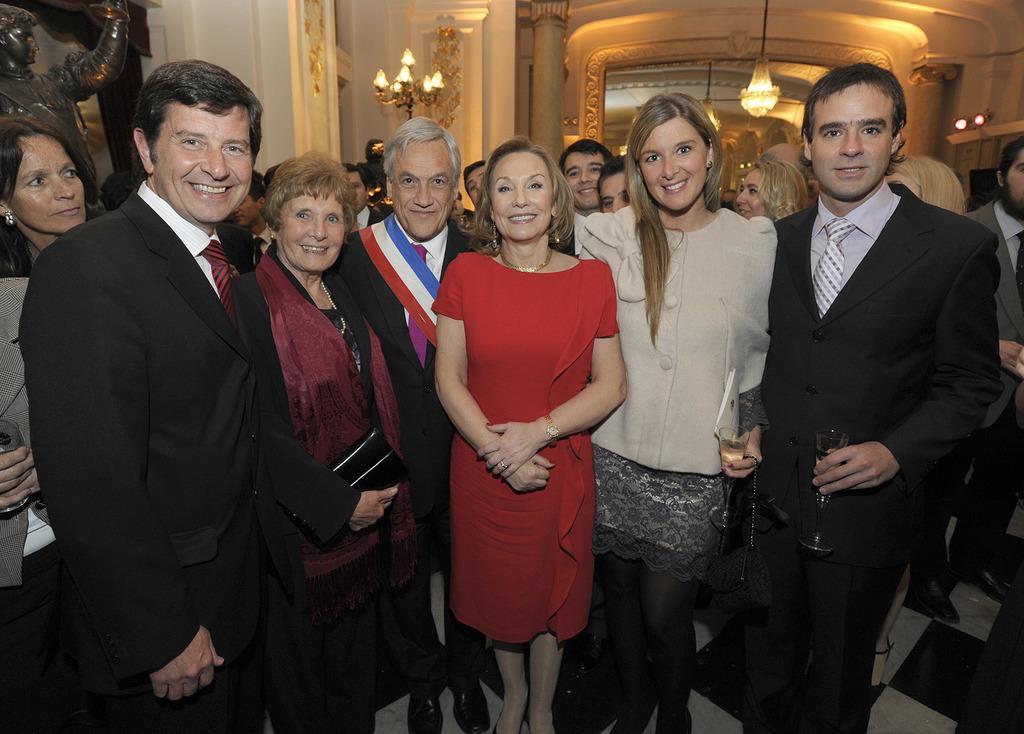Could you give a brief overview of what you see in this image? In this image there are people standing on the floor. Right side there is a person wearing a blazer and tie. He is standing on the floor. He is holding a glass in his hand. The glass is filled with the drink. Beside him there is a woman holding a glass. There are chandeliers hanging from the roof. Left side there is a statue. There are lights attached to a stand. Background there is a wall. 